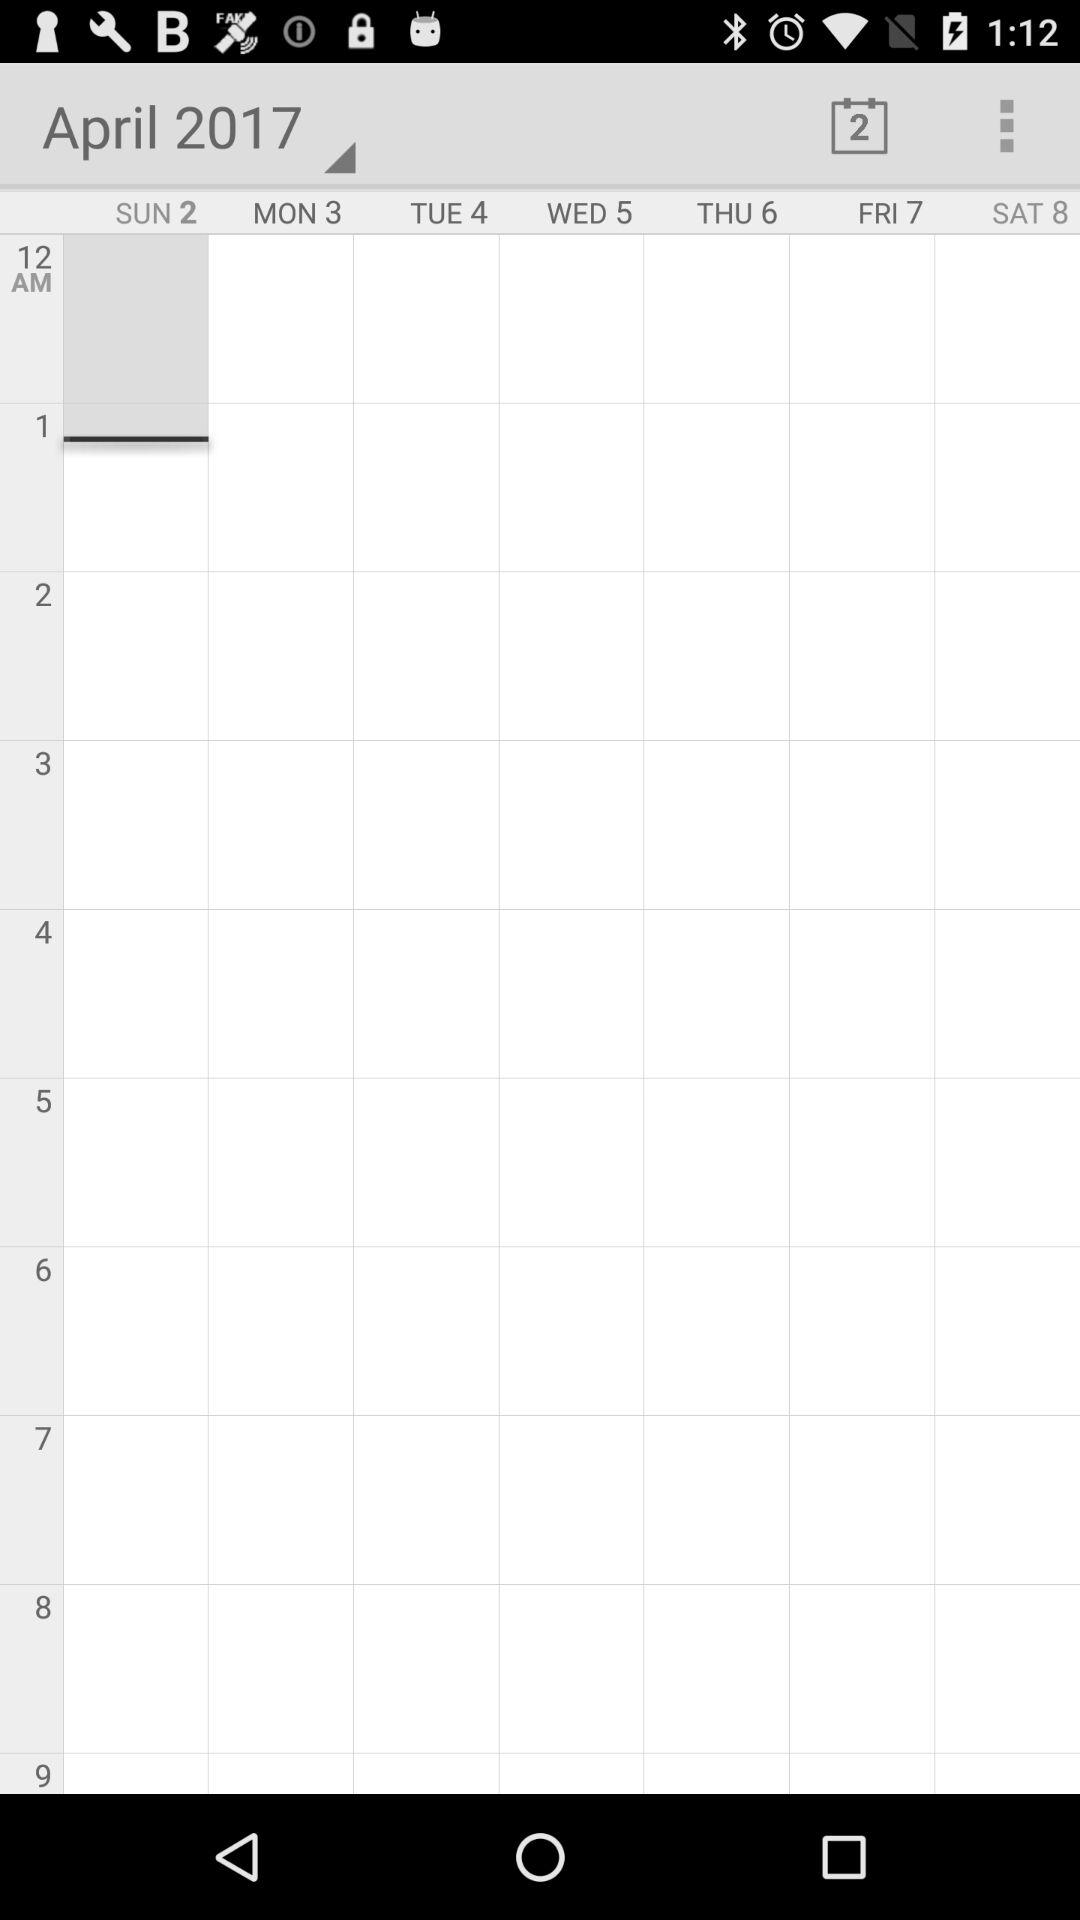Which day is April 2, 2017? The day is Sunday. 